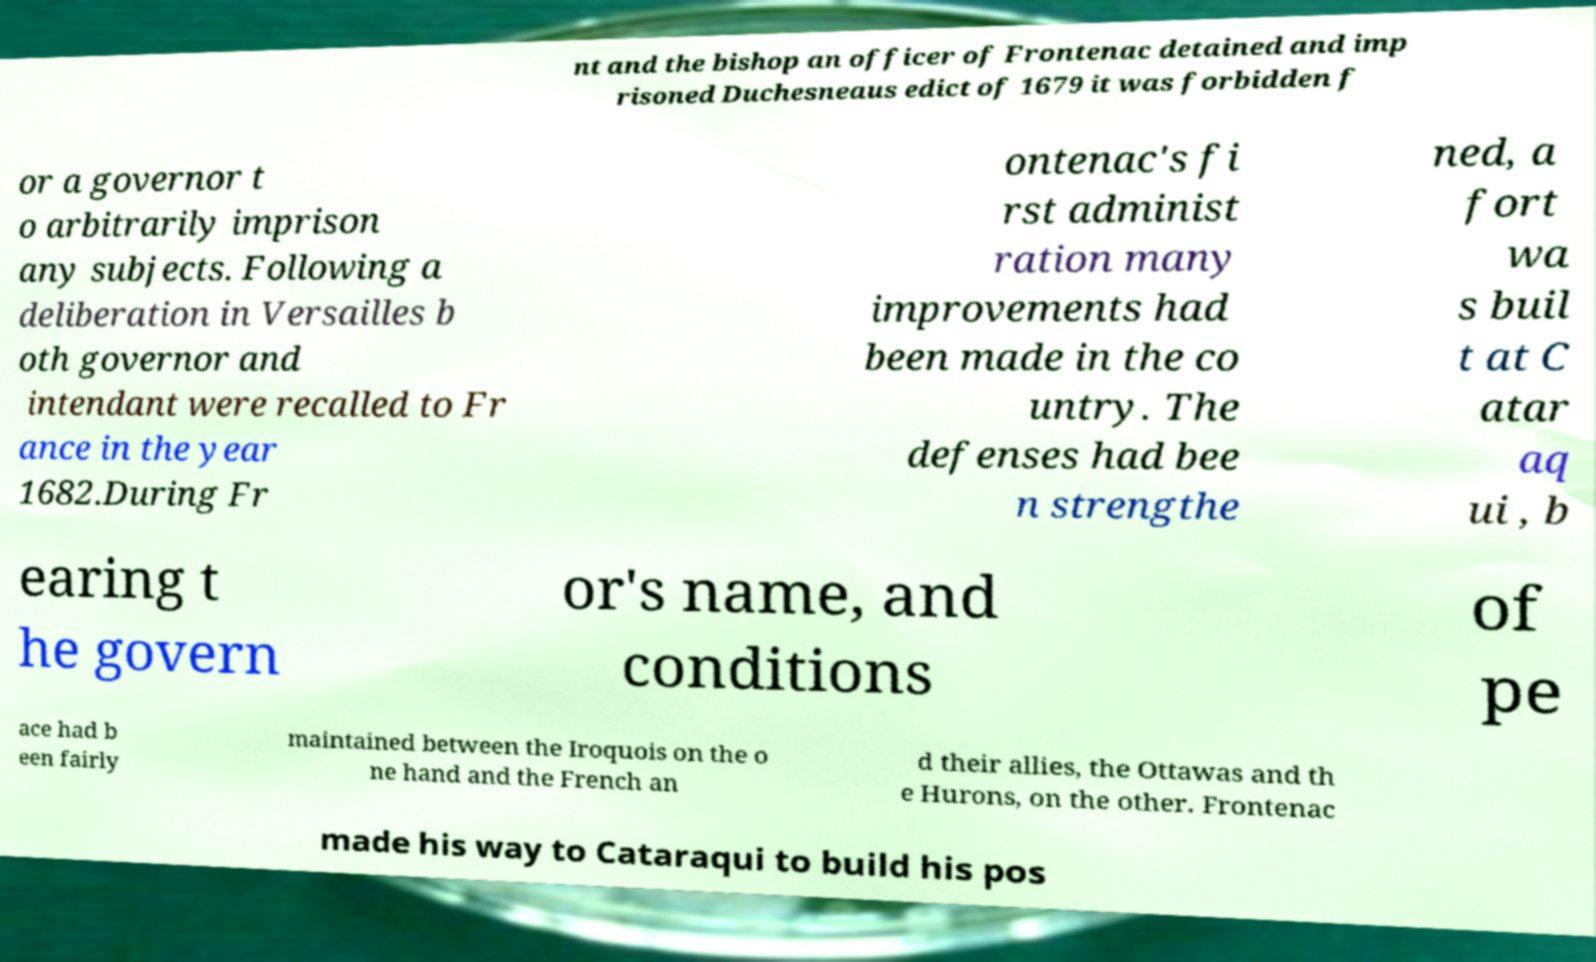For documentation purposes, I need the text within this image transcribed. Could you provide that? nt and the bishop an officer of Frontenac detained and imp risoned Duchesneaus edict of 1679 it was forbidden f or a governor t o arbitrarily imprison any subjects. Following a deliberation in Versailles b oth governor and intendant were recalled to Fr ance in the year 1682.During Fr ontenac's fi rst administ ration many improvements had been made in the co untry. The defenses had bee n strengthe ned, a fort wa s buil t at C atar aq ui , b earing t he govern or's name, and conditions of pe ace had b een fairly maintained between the Iroquois on the o ne hand and the French an d their allies, the Ottawas and th e Hurons, on the other. Frontenac made his way to Cataraqui to build his pos 